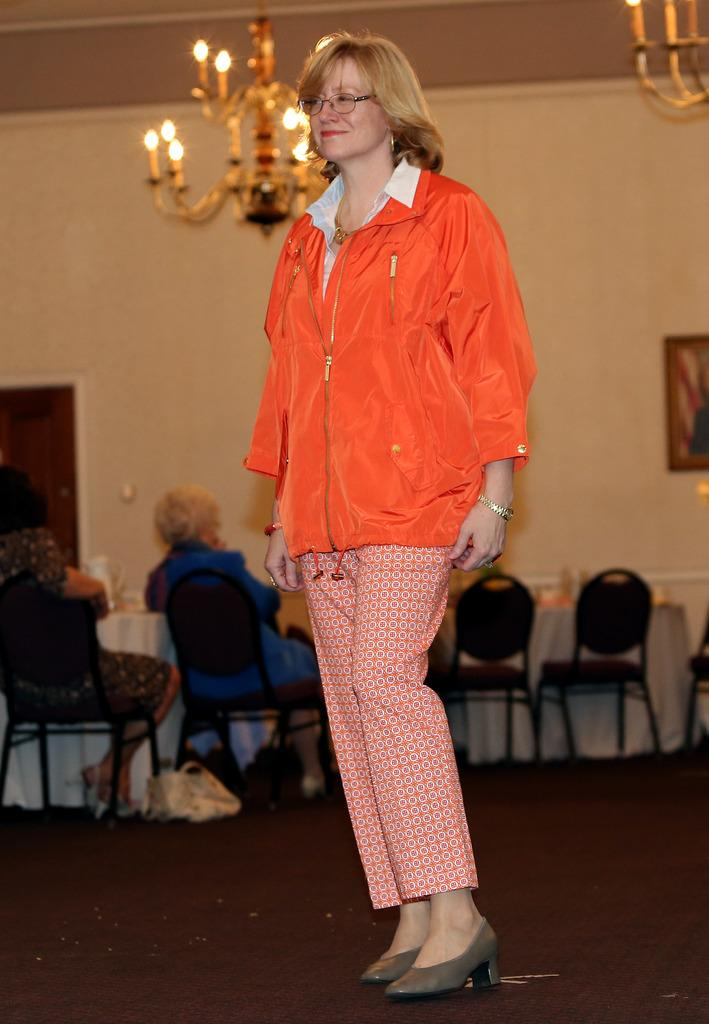What is the primary action of the person in the image? There is a person standing in the image. What are the other people in the image doing? There are people sitting in the image. What can be seen illuminating the scene in the image? There are lights visible in the image. What type of decorative elements are attached to the wall in the image? There are frames attached to the wall in the image. What type of grain is being served with the fork in the image? There is no grain or fork present in the image. How does the person move around in the image? The person's movement cannot be determined from the image, as it only shows a person standing still. 